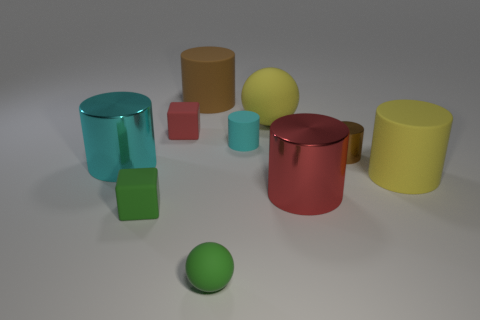What is the size of the matte thing that is the same color as the small matte ball? The small matte ball appears to be green, and so is the small cube. The size of the matte cube that matches the color of the small matte ball is relatively small, comparable in size to the ball itself. 